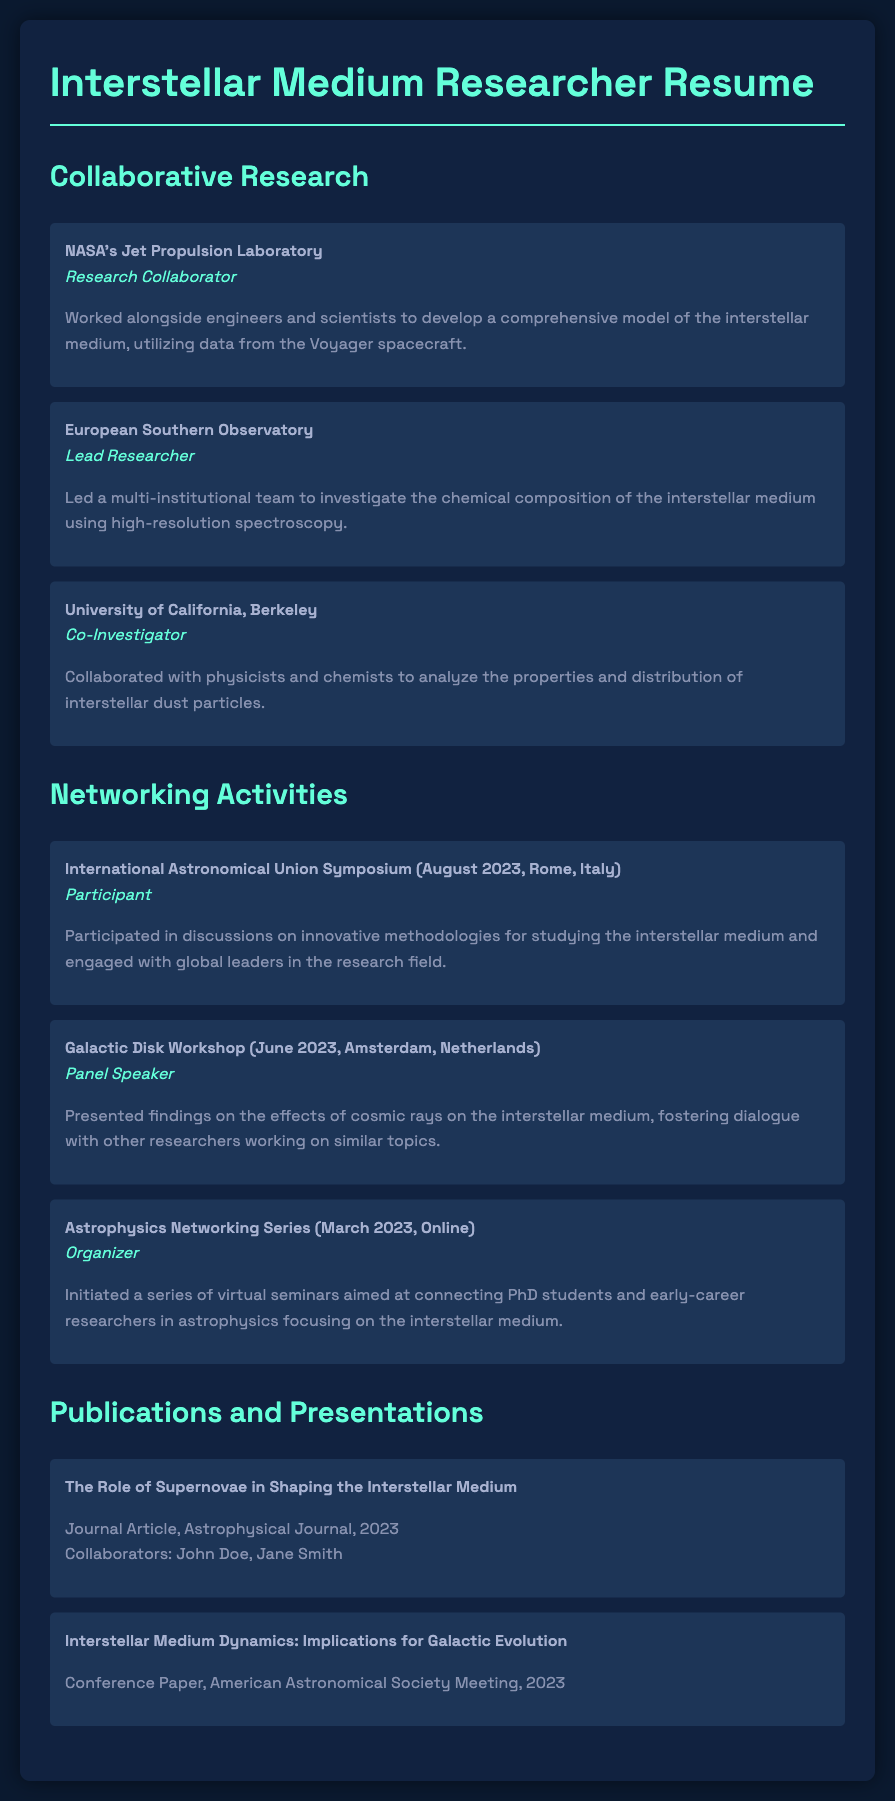What institution was involved in developing a model of the interstellar medium? The document states that NASA's Jet Propulsion Laboratory was involved in developing a model of the interstellar medium.
Answer: NASA's Jet Propulsion Laboratory Who was the lead researcher for the project with the European Southern Observatory? The lead researcher for the project with the European Southern Observatory is mentioned in the document as being the author of the resume.
Answer: Lead Researcher What was the title of the paper presented at the American Astronomical Society Meeting? The document lists "Interstellar Medium Dynamics: Implications for Galactic Evolution" as the title of the paper presented at the American Astronomical Society Meeting.
Answer: Interstellar Medium Dynamics: Implications for Galactic Evolution Which symposium did the participant attend in August 2023? The document specifies that the participant attended the International Astronomical Union Symposium in August 2023.
Answer: International Astronomical Union Symposium What role did the author play in the Astrophysics Networking Series? The author is identified in the document as the organizer of the Astrophysics Networking Series.
Answer: Organizer At which event did the author present findings on cosmic rays? The document states that the author presented findings on cosmic rays at the Galactic Disk Workshop.
Answer: Galactic Disk Workshop How many collaborators are mentioned for the journal article in the publication section? The document indicates that there are two collaborators mentioned for the journal article.
Answer: Two In which city was the Galactic Disk Workshop held? The document states that the Galactic Disk Workshop was held in Amsterdam, Netherlands.
Answer: Amsterdam, Netherlands What type of publication is "The Role of Supernovae in Shaping the Interstellar Medium"? According to the document, it is a journal article published in the Astrophysical Journal.
Answer: Journal Article 